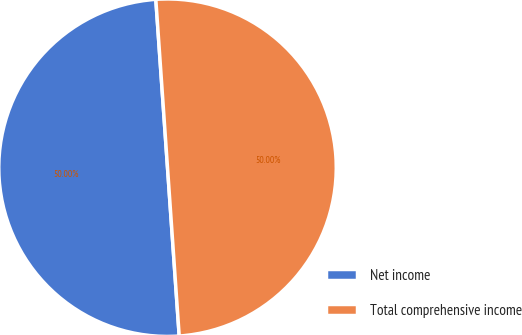Convert chart to OTSL. <chart><loc_0><loc_0><loc_500><loc_500><pie_chart><fcel>Net income<fcel>Total comprehensive income<nl><fcel>50.0%<fcel>50.0%<nl></chart> 